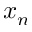Convert formula to latex. <formula><loc_0><loc_0><loc_500><loc_500>x _ { n }</formula> 